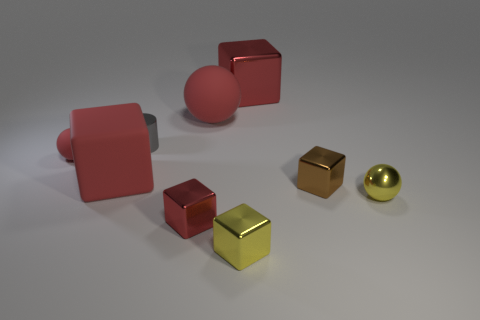Are the gray thing and the large red ball made of the same material?
Offer a very short reply. No. The tiny metal object that is both behind the small yellow metallic ball and left of the small brown cube has what shape?
Keep it short and to the point. Cylinder. The small gray object that is made of the same material as the brown object is what shape?
Ensure brevity in your answer.  Cylinder. Is there a small purple rubber cylinder?
Give a very brief answer. No. Is there a tiny object to the left of the large object to the left of the tiny metal cylinder?
Offer a very short reply. Yes. There is a yellow thing that is the same shape as the small brown thing; what is its material?
Provide a succinct answer. Metal. Are there more large cyan blocks than yellow metal balls?
Your response must be concise. No. There is a big shiny block; is its color the same as the small sphere behind the metal sphere?
Your answer should be compact. Yes. What color is the metal object that is both on the left side of the big sphere and in front of the small gray cylinder?
Give a very brief answer. Red. What number of other objects are the same material as the large sphere?
Provide a short and direct response. 2. 